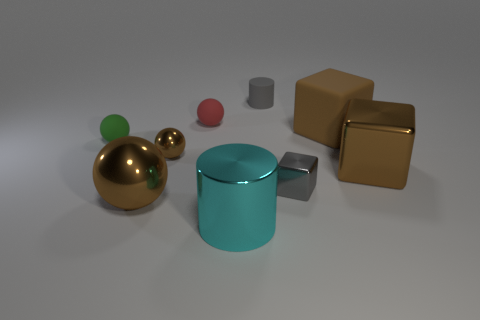How many gray matte objects have the same size as the gray metallic cube?
Provide a short and direct response. 1. There is a gray object that is in front of the red ball; does it have the same size as the cylinder in front of the small gray rubber cylinder?
Offer a very short reply. No. Is the number of brown metal balls behind the big brown metallic ball greater than the number of small green rubber balls on the right side of the green object?
Your answer should be compact. Yes. What number of other red objects are the same shape as the small red rubber object?
Ensure brevity in your answer.  0. What material is the cube that is the same size as the red rubber ball?
Provide a succinct answer. Metal. Are there any small purple things made of the same material as the green ball?
Offer a terse response. No. Is the number of brown things behind the green matte object less than the number of large purple rubber things?
Your response must be concise. No. What is the material of the sphere in front of the tiny cube left of the brown rubber thing?
Offer a very short reply. Metal. There is a brown shiny thing that is both on the left side of the gray cylinder and in front of the tiny brown shiny thing; what is its shape?
Your answer should be very brief. Sphere. What number of other things are the same color as the large metallic cylinder?
Give a very brief answer. 0. 